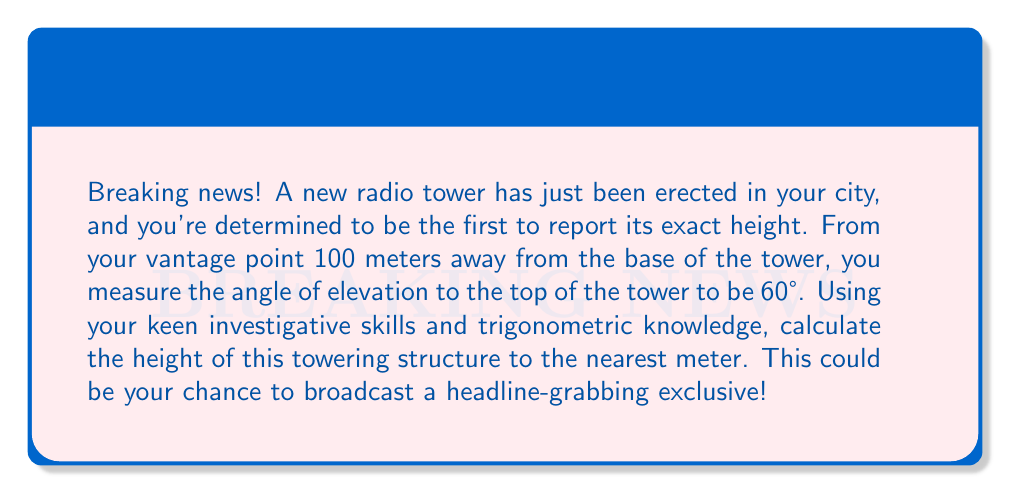Solve this math problem. Let's approach this step-by-step using trigonometry:

1) First, let's visualize the problem:

[asy]
import geometry;

size(200);
pair A = (0,0), B = (5,0), C = (5,8.66);
draw(A--B--C--A);
label("100 m", (2.5,0), S);
label("h", (5,4.33), E);
label("60°", A, SW);
dot("A", A, SW);
dot("B", B, SE);
dot("C", C, NE);
[/asy]

2) We have a right-angled triangle where:
   - The adjacent side is the distance from you to the base of the tower (100 m)
   - The opposite side is the height of the tower (h)
   - The angle of elevation is 60°

3) In this scenario, we can use the tangent function:

   $$\tan(\theta) = \frac{\text{opposite}}{\text{adjacent}}$$

4) Substituting our known values:

   $$\tan(60°) = \frac{h}{100}$$

5) We know that $\tan(60°) = \sqrt{3}$, so:

   $$\sqrt{3} = \frac{h}{100}$$

6) Solving for h:

   $$h = 100 \sqrt{3}$$

7) Calculate the value:

   $$h \approx 173.2 \text{ meters}$$

8) Rounding to the nearest meter:

   $$h \approx 173 \text{ meters}$$
Answer: 173 meters 